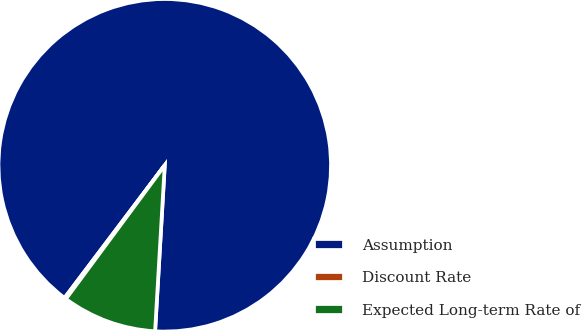<chart> <loc_0><loc_0><loc_500><loc_500><pie_chart><fcel>Assumption<fcel>Discount Rate<fcel>Expected Long-term Rate of<nl><fcel>90.63%<fcel>0.16%<fcel>9.21%<nl></chart> 